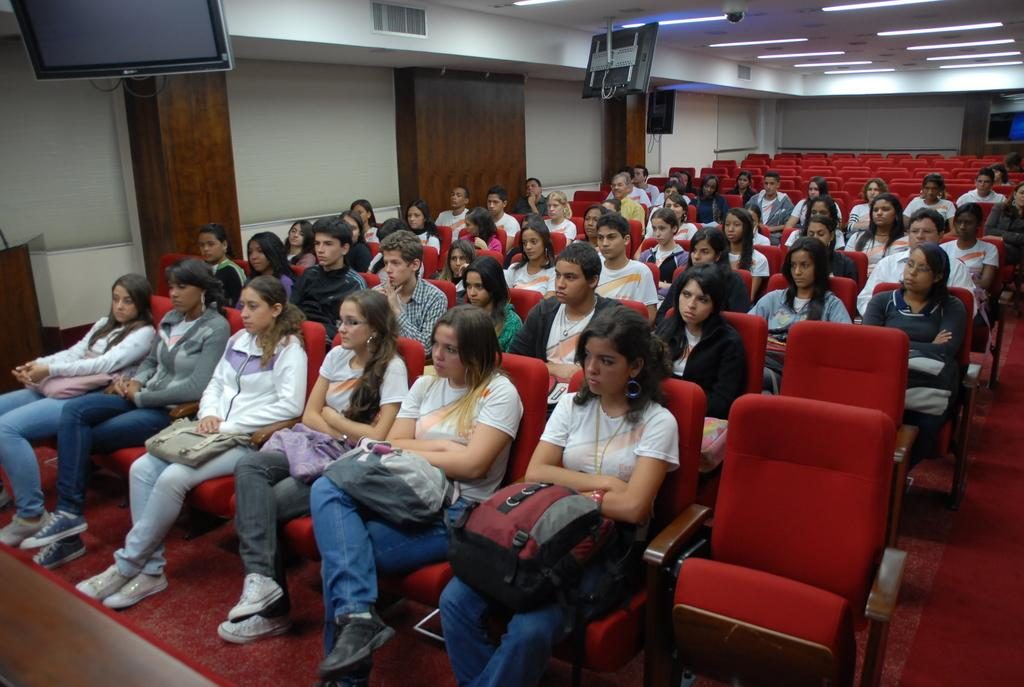What are the people in the image doing? The people in the image are sitting on chairs. What can be seen in the background of the image? There is a wall in the background of the image. What is above the people in the image? There is a ceiling visible in the image. What type of lighting is present in the image? Lights are present in the image. What electronic devices can be seen in the image? Monitors are visible in the image. How does the rain affect the people sitting on chairs in the image? There is no rain present in the image; it is an indoor setting with a ceiling and wall. 